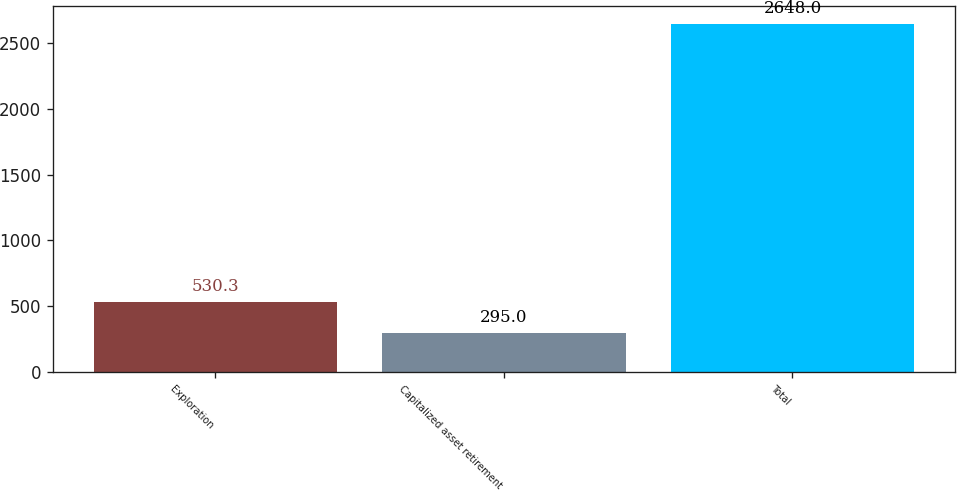Convert chart to OTSL. <chart><loc_0><loc_0><loc_500><loc_500><bar_chart><fcel>Exploration<fcel>Capitalized asset retirement<fcel>Total<nl><fcel>530.3<fcel>295<fcel>2648<nl></chart> 